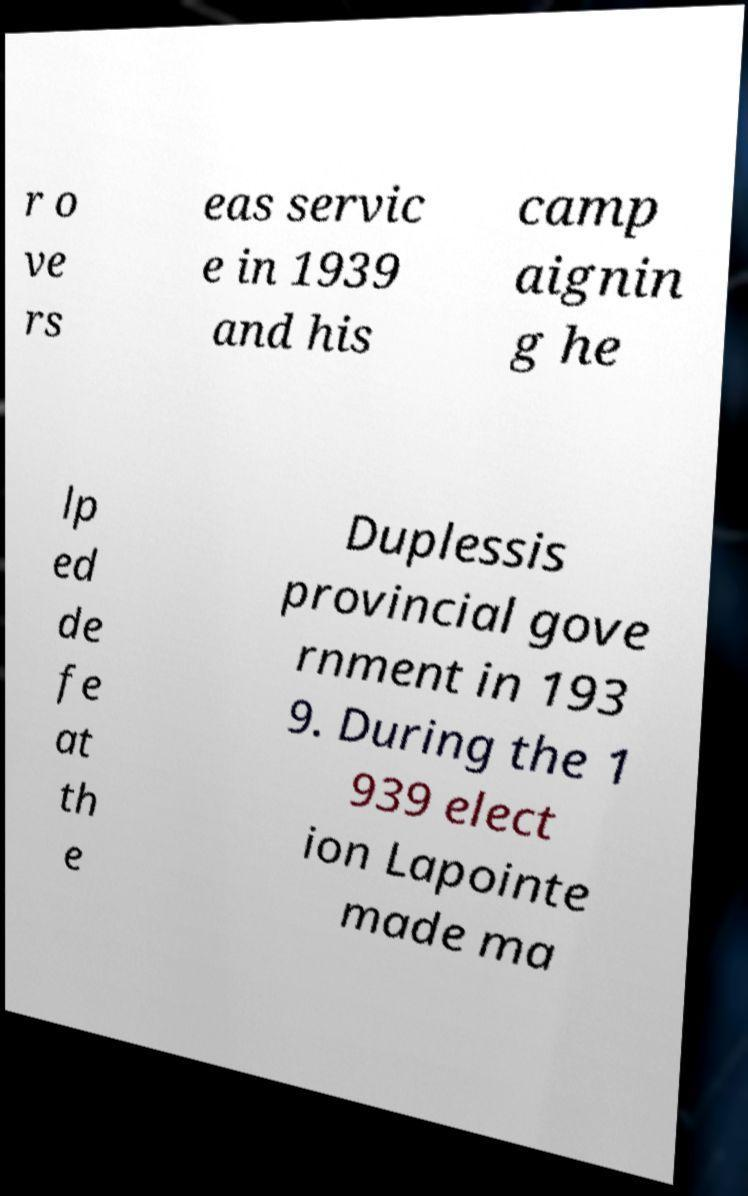Please identify and transcribe the text found in this image. r o ve rs eas servic e in 1939 and his camp aignin g he lp ed de fe at th e Duplessis provincial gove rnment in 193 9. During the 1 939 elect ion Lapointe made ma 